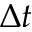<formula> <loc_0><loc_0><loc_500><loc_500>\Delta t</formula> 